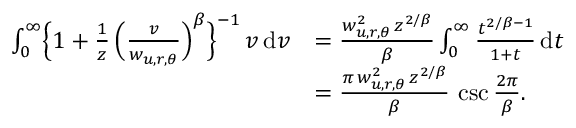<formula> <loc_0><loc_0><loc_500><loc_500>\begin{array} { r l } { \int _ { 0 } ^ { \infty } \left \{ 1 + \frac { 1 } { z } \, \left ( \frac { v } { w _ { u , r , \theta } } \right ) ^ { \beta } \right \} ^ { - 1 } \, v \, d v } & { = \frac { w _ { u , r , \theta } ^ { 2 } \, z ^ { 2 / \beta } } { \beta } \int _ { 0 } ^ { \infty } \frac { t ^ { 2 / \beta - 1 } } { 1 + t } \, d t } \\ & { = \frac { \pi \, w _ { u , r , \theta } ^ { 2 } \, z ^ { 2 / \beta } } { \beta } \, \csc \frac { 2 \pi } { \beta } . } \end{array}</formula> 